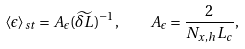Convert formula to latex. <formula><loc_0><loc_0><loc_500><loc_500>\langle \epsilon \rangle _ { s t } = A _ { \epsilon } ( \widetilde { \delta L } ) ^ { - 1 } , \quad A _ { \epsilon } = \frac { 2 } { N _ { x , h } L _ { c } } ,</formula> 